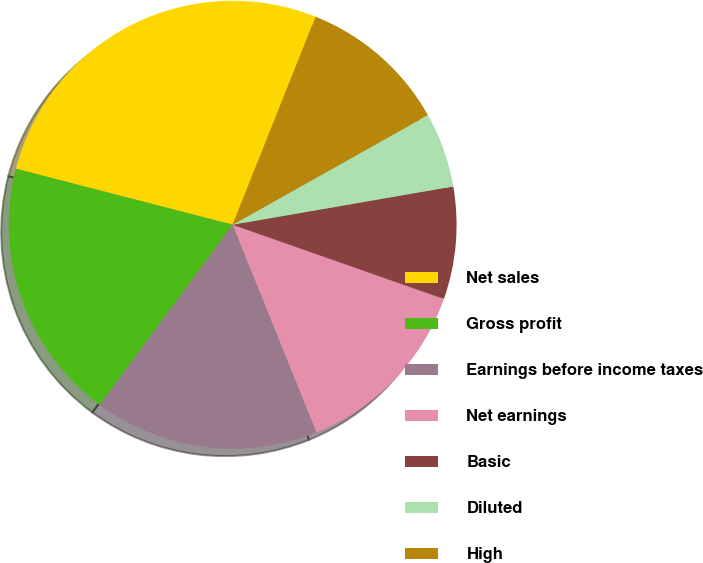Convert chart to OTSL. <chart><loc_0><loc_0><loc_500><loc_500><pie_chart><fcel>Net sales<fcel>Gross profit<fcel>Earnings before income taxes<fcel>Net earnings<fcel>Basic<fcel>Diluted<fcel>High<fcel>Dividends declared per share<nl><fcel>27.02%<fcel>18.92%<fcel>16.22%<fcel>13.51%<fcel>8.11%<fcel>5.41%<fcel>10.81%<fcel>0.0%<nl></chart> 